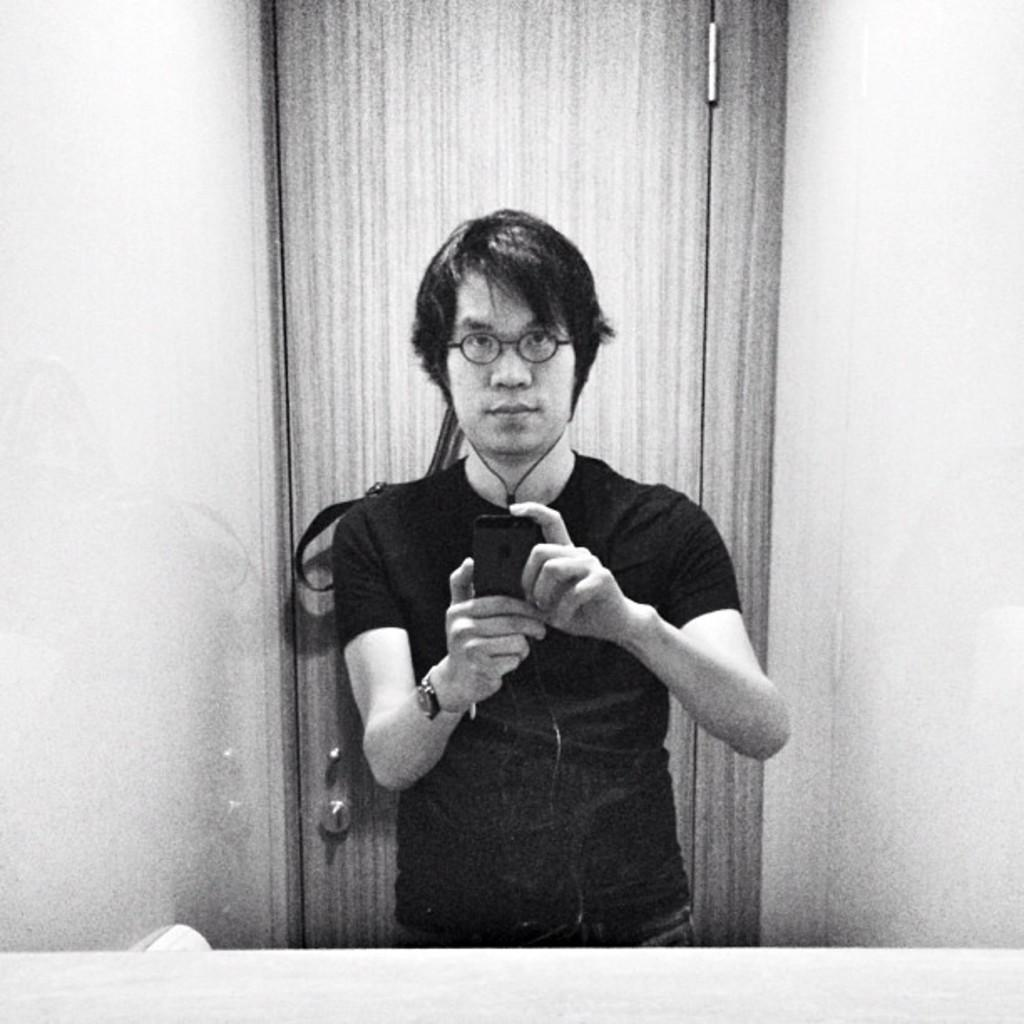What is the main subject of the picture? The main subject of the picture is a man. What is the man doing in the picture? The man is standing in the picture. What object is the man holding in the picture? The man is holding a mobile phone in the picture. What accessory is the man wearing in the picture? The man is wearing spectacles in the picture. What can be seen behind the man in the picture? There is a mirror in front of the man in the picture. What invention is the man demonstrating in the picture? There is no invention being demonstrated in the picture; the man is simply standing and holding a mobile phone. How many balls can be seen in the picture? There are no balls present in the picture. 